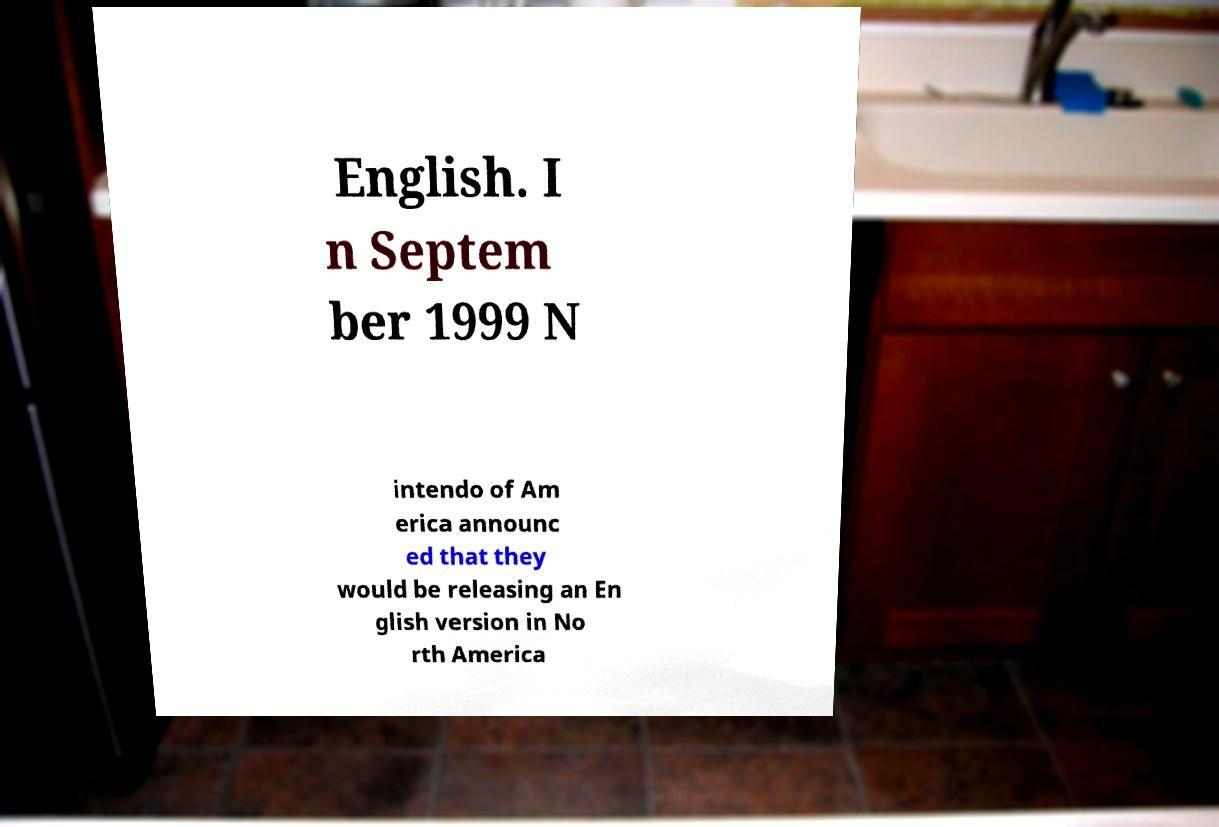Could you extract and type out the text from this image? English. I n Septem ber 1999 N intendo of Am erica announc ed that they would be releasing an En glish version in No rth America 